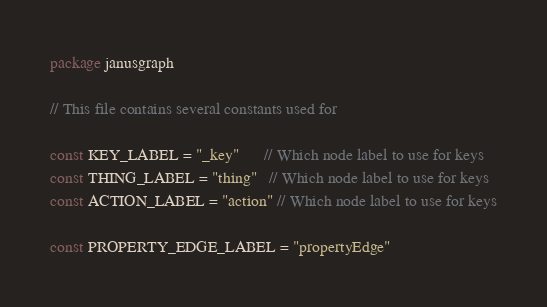<code> <loc_0><loc_0><loc_500><loc_500><_Go_>package janusgraph

// This file contains several constants used for

const KEY_LABEL = "_key"      // Which node label to use for keys
const THING_LABEL = "thing"   // Which node label to use for keys
const ACTION_LABEL = "action" // Which node label to use for keys

const PROPERTY_EDGE_LABEL = "propertyEdge"
</code> 